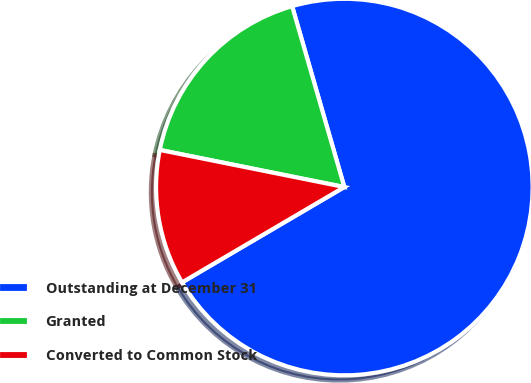<chart> <loc_0><loc_0><loc_500><loc_500><pie_chart><fcel>Outstanding at December 31<fcel>Granted<fcel>Converted to Common Stock<nl><fcel>71.02%<fcel>17.37%<fcel>11.61%<nl></chart> 